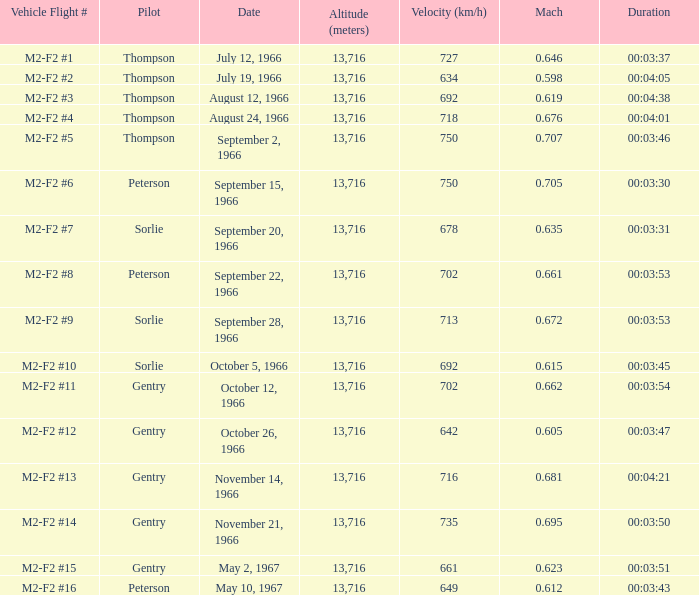What is the Mach with Vehicle Flight # m2-f2 #8 and an Altitude (meters) greater than 13,716? None. 